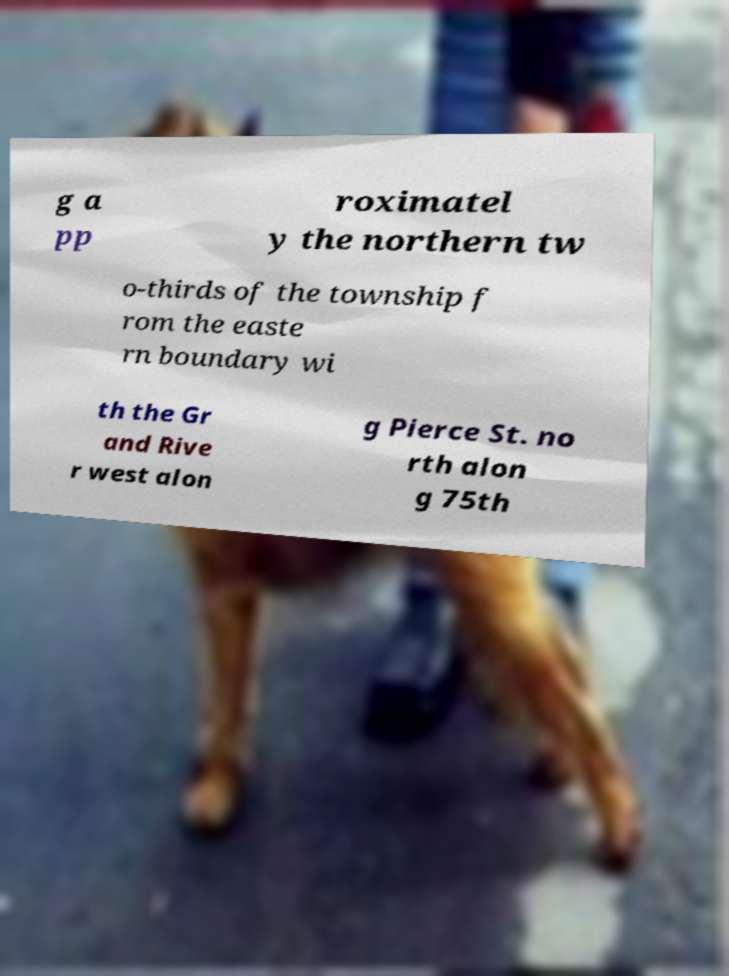There's text embedded in this image that I need extracted. Can you transcribe it verbatim? g a pp roximatel y the northern tw o-thirds of the township f rom the easte rn boundary wi th the Gr and Rive r west alon g Pierce St. no rth alon g 75th 